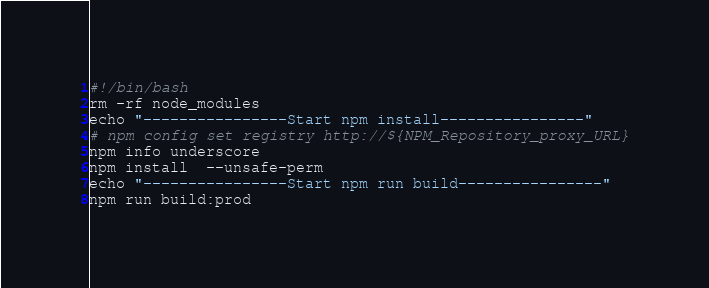Convert code to text. <code><loc_0><loc_0><loc_500><loc_500><_Bash_>#!/bin/bash
rm -rf node_modules
echo "----------------Start npm install----------------"
# npm config set registry http://${NPM_Repository_proxy_URL}
npm info underscore
npm install  --unsafe-perm
echo "----------------Start npm run build----------------"
npm run build:prod
</code> 